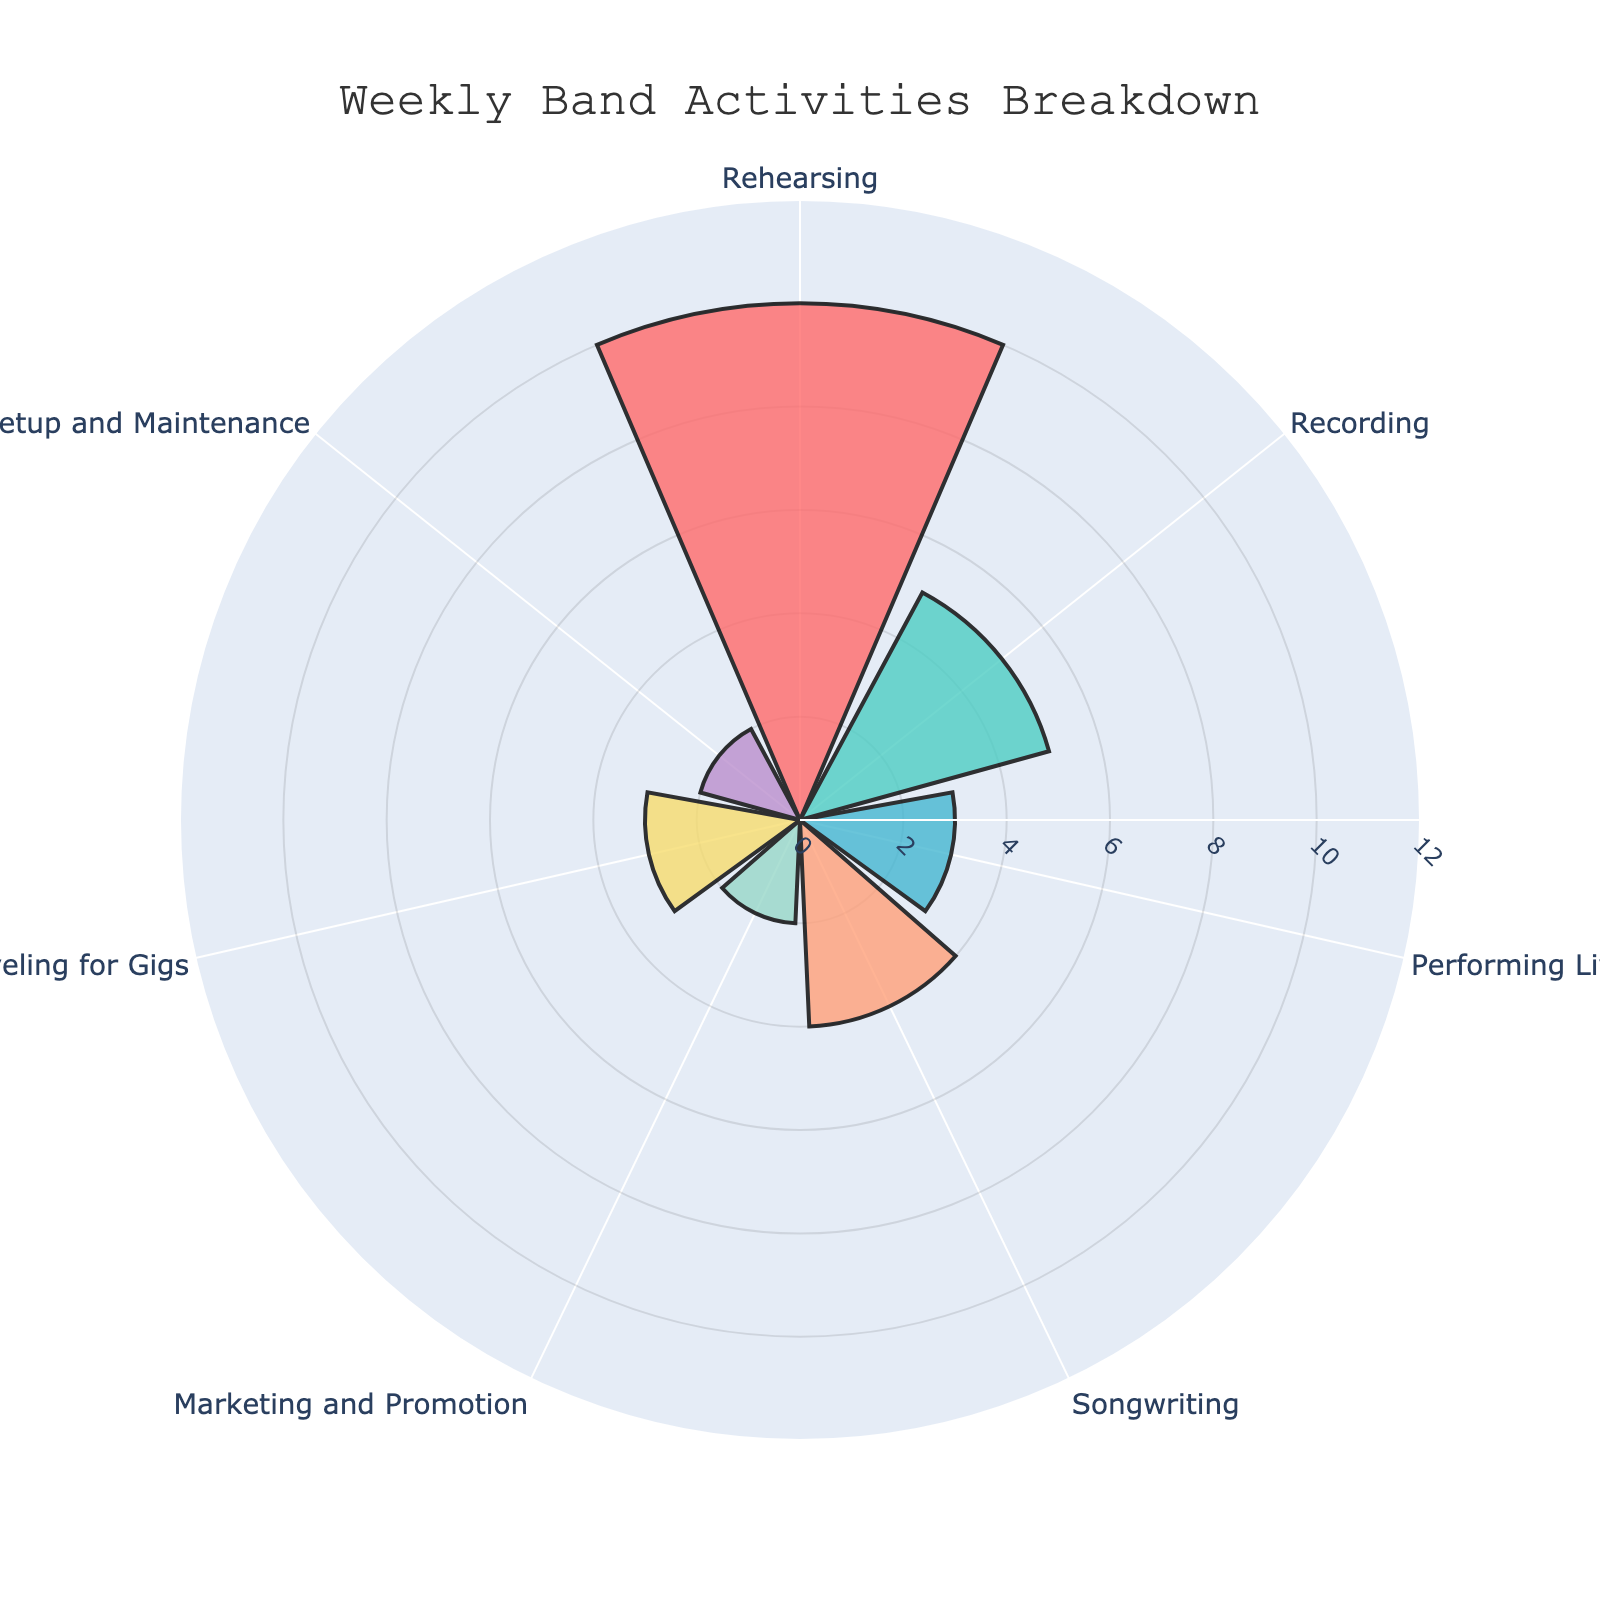What is the title of the rose chart? The title is prominently displayed at the top of the chart.
Answer: Weekly Band Activities Breakdown Which activity is represented with the most hours per week? The activity with the longest bar reaching 10 hours is the one spent the most on.
Answer: Rehearsing What color is used to represent the hours spent Recording? The bars representing Recording are shown in a specific color, which can be identified visually.
Answer: Light green How many hours per week are spent on Marketing and Promotion and Equipment Setup and Maintenance combined? Sum the hours for these two activities (2 hours for Marketing and Promotion + 2 hours for Equipment Setup and Maintenance = 4 hours).
Answer: 4 hours How does the time spent on Performing Live compare to the time spent Traveling for Gigs? Both bars for these activities should be visually compared for length, both representing the same number of hours per week (3 hours).
Answer: Equal Which activity spends the least amount of time per week? The activity with the shortest bar is the one with the least time.
Answer: Marketing and Promotion What is the average number of hours spent on all activities per week? Add up all hours (10 + 5 + 3 + 4 + 2 + 3 + 2 = 29) and divide by the number of activities (7).
Answer: 4.14 hours What color is used for the activity with 4 hours per week? Identify the color of the bar that represents the 4 hours of Songwriting.
Answer: Light blue What is the difference in hours spent between Rehearsing and Songwriting? Rehearsing (10 hours) minus Songwriting (4 hours) equals the difference.
Answer: 6 hours If the band decides to double the time spent on Recording, how many hours will be spent on it per week? Double the current hours spent on Recording (5 hours * 2 = 10 hours).
Answer: 10 hours 